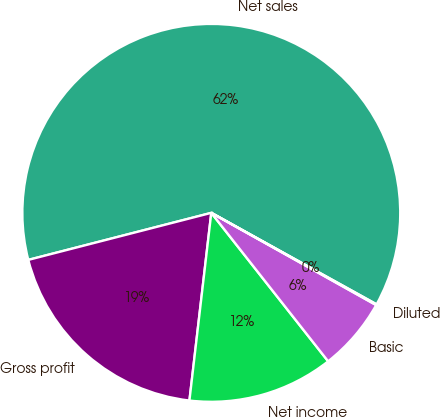Convert chart to OTSL. <chart><loc_0><loc_0><loc_500><loc_500><pie_chart><fcel>Net sales<fcel>Gross profit<fcel>Net income<fcel>Basic<fcel>Diluted<nl><fcel>62.05%<fcel>19.15%<fcel>12.46%<fcel>6.27%<fcel>0.07%<nl></chart> 